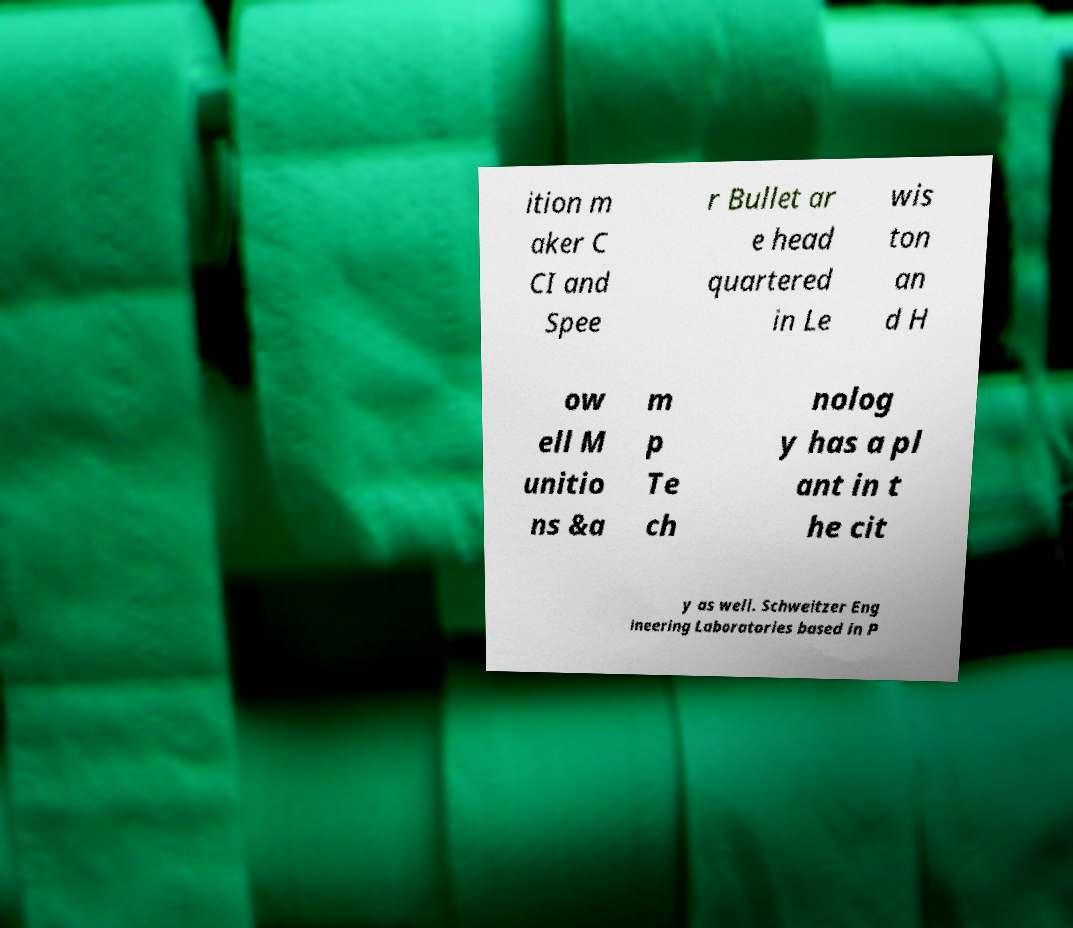What messages or text are displayed in this image? I need them in a readable, typed format. ition m aker C CI and Spee r Bullet ar e head quartered in Le wis ton an d H ow ell M unitio ns &a m p Te ch nolog y has a pl ant in t he cit y as well. Schweitzer Eng ineering Laboratories based in P 